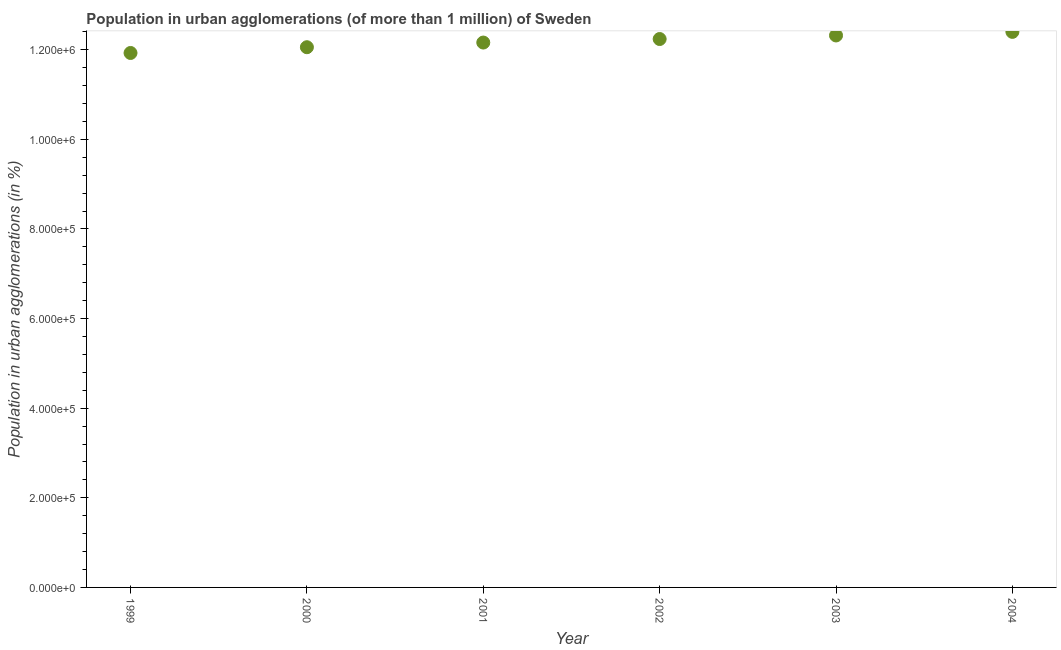What is the population in urban agglomerations in 1999?
Make the answer very short. 1.19e+06. Across all years, what is the maximum population in urban agglomerations?
Offer a very short reply. 1.24e+06. Across all years, what is the minimum population in urban agglomerations?
Your answer should be very brief. 1.19e+06. In which year was the population in urban agglomerations maximum?
Your answer should be very brief. 2004. What is the sum of the population in urban agglomerations?
Keep it short and to the point. 7.31e+06. What is the difference between the population in urban agglomerations in 2001 and 2003?
Your response must be concise. -1.58e+04. What is the average population in urban agglomerations per year?
Provide a short and direct response. 1.22e+06. What is the median population in urban agglomerations?
Your answer should be very brief. 1.22e+06. What is the ratio of the population in urban agglomerations in 2003 to that in 2004?
Offer a very short reply. 0.99. What is the difference between the highest and the second highest population in urban agglomerations?
Provide a succinct answer. 8001. What is the difference between the highest and the lowest population in urban agglomerations?
Ensure brevity in your answer.  4.71e+04. In how many years, is the population in urban agglomerations greater than the average population in urban agglomerations taken over all years?
Your answer should be compact. 3. How many years are there in the graph?
Your answer should be very brief. 6. Does the graph contain any zero values?
Your answer should be compact. No. What is the title of the graph?
Give a very brief answer. Population in urban agglomerations (of more than 1 million) of Sweden. What is the label or title of the X-axis?
Give a very brief answer. Year. What is the label or title of the Y-axis?
Ensure brevity in your answer.  Population in urban agglomerations (in %). What is the Population in urban agglomerations (in %) in 1999?
Ensure brevity in your answer.  1.19e+06. What is the Population in urban agglomerations (in %) in 2000?
Your answer should be compact. 1.21e+06. What is the Population in urban agglomerations (in %) in 2001?
Offer a terse response. 1.22e+06. What is the Population in urban agglomerations (in %) in 2002?
Make the answer very short. 1.22e+06. What is the Population in urban agglomerations (in %) in 2003?
Keep it short and to the point. 1.23e+06. What is the Population in urban agglomerations (in %) in 2004?
Offer a terse response. 1.24e+06. What is the difference between the Population in urban agglomerations (in %) in 1999 and 2000?
Give a very brief answer. -1.29e+04. What is the difference between the Population in urban agglomerations (in %) in 1999 and 2001?
Your response must be concise. -2.33e+04. What is the difference between the Population in urban agglomerations (in %) in 1999 and 2002?
Provide a succinct answer. -3.11e+04. What is the difference between the Population in urban agglomerations (in %) in 1999 and 2003?
Offer a very short reply. -3.91e+04. What is the difference between the Population in urban agglomerations (in %) in 1999 and 2004?
Make the answer very short. -4.71e+04. What is the difference between the Population in urban agglomerations (in %) in 2000 and 2001?
Provide a short and direct response. -1.04e+04. What is the difference between the Population in urban agglomerations (in %) in 2000 and 2002?
Offer a very short reply. -1.83e+04. What is the difference between the Population in urban agglomerations (in %) in 2000 and 2003?
Your response must be concise. -2.62e+04. What is the difference between the Population in urban agglomerations (in %) in 2000 and 2004?
Offer a very short reply. -3.42e+04. What is the difference between the Population in urban agglomerations (in %) in 2001 and 2002?
Give a very brief answer. -7887. What is the difference between the Population in urban agglomerations (in %) in 2001 and 2003?
Keep it short and to the point. -1.58e+04. What is the difference between the Population in urban agglomerations (in %) in 2001 and 2004?
Ensure brevity in your answer.  -2.38e+04. What is the difference between the Population in urban agglomerations (in %) in 2002 and 2003?
Offer a terse response. -7939. What is the difference between the Population in urban agglomerations (in %) in 2002 and 2004?
Provide a succinct answer. -1.59e+04. What is the difference between the Population in urban agglomerations (in %) in 2003 and 2004?
Your response must be concise. -8001. What is the ratio of the Population in urban agglomerations (in %) in 1999 to that in 2002?
Give a very brief answer. 0.97. What is the ratio of the Population in urban agglomerations (in %) in 1999 to that in 2004?
Offer a terse response. 0.96. What is the ratio of the Population in urban agglomerations (in %) in 2000 to that in 2001?
Offer a terse response. 0.99. What is the ratio of the Population in urban agglomerations (in %) in 2000 to that in 2002?
Provide a succinct answer. 0.98. What is the ratio of the Population in urban agglomerations (in %) in 2000 to that in 2004?
Your answer should be compact. 0.97. What is the ratio of the Population in urban agglomerations (in %) in 2001 to that in 2002?
Offer a terse response. 0.99. What is the ratio of the Population in urban agglomerations (in %) in 2001 to that in 2003?
Offer a terse response. 0.99. What is the ratio of the Population in urban agglomerations (in %) in 2001 to that in 2004?
Make the answer very short. 0.98. What is the ratio of the Population in urban agglomerations (in %) in 2002 to that in 2004?
Provide a short and direct response. 0.99. What is the ratio of the Population in urban agglomerations (in %) in 2003 to that in 2004?
Offer a terse response. 0.99. 